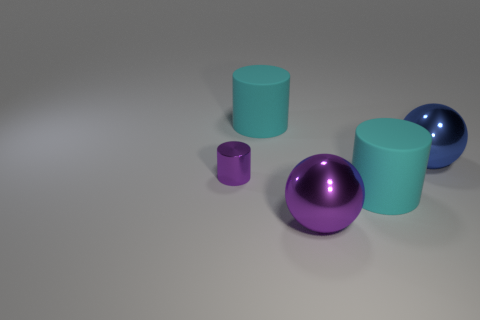The shiny thing that is the same color as the metallic cylinder is what size?
Keep it short and to the point. Large. Is there anything else that is the same size as the purple cylinder?
Provide a short and direct response. No. Do the metallic cylinder and the blue ball have the same size?
Offer a very short reply. No. There is a large sphere on the right side of the large metallic sphere in front of the big blue sphere; what is its material?
Your response must be concise. Metal. Is there a big shiny object that has the same shape as the tiny purple metallic thing?
Provide a succinct answer. No. Is the size of the blue shiny sphere the same as the ball that is left of the big blue metal sphere?
Offer a terse response. Yes. What number of things are rubber things behind the purple cylinder or large cyan things in front of the metallic cylinder?
Your answer should be compact. 2. Are there more big things in front of the tiny metal cylinder than red shiny objects?
Provide a short and direct response. Yes. How many spheres are the same size as the purple metal cylinder?
Give a very brief answer. 0. There is a cyan cylinder behind the blue metal ball; is it the same size as the metallic ball on the right side of the purple shiny sphere?
Your answer should be compact. Yes. 